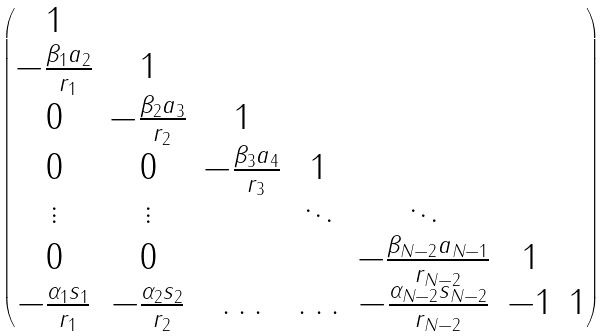Convert formula to latex. <formula><loc_0><loc_0><loc_500><loc_500>\begin{pmatrix} 1 \\ - \frac { \beta _ { 1 } a _ { 2 } } { r _ { 1 } } & 1 \\ 0 & - \frac { \beta _ { 2 } a _ { 3 } } { r _ { 2 } } & 1 \\ 0 & 0 & - \frac { \beta _ { 3 } a _ { 4 } } { r _ { 3 } } & 1 \\ \vdots & \vdots & & \ddots & \ddots \\ 0 & 0 & & & - \frac { \beta _ { N - 2 } a _ { N - 1 } } { r _ { N - 2 } } & 1 \\ - \frac { \alpha _ { 1 } s _ { 1 } } { r _ { 1 } } & - \frac { \alpha _ { 2 } s _ { 2 } } { r _ { 2 } } & \hdots & \hdots & - \frac { \alpha _ { N - 2 } s _ { N - 2 } } { r _ { N - 2 } } & - 1 & 1 \\ \end{pmatrix}</formula> 